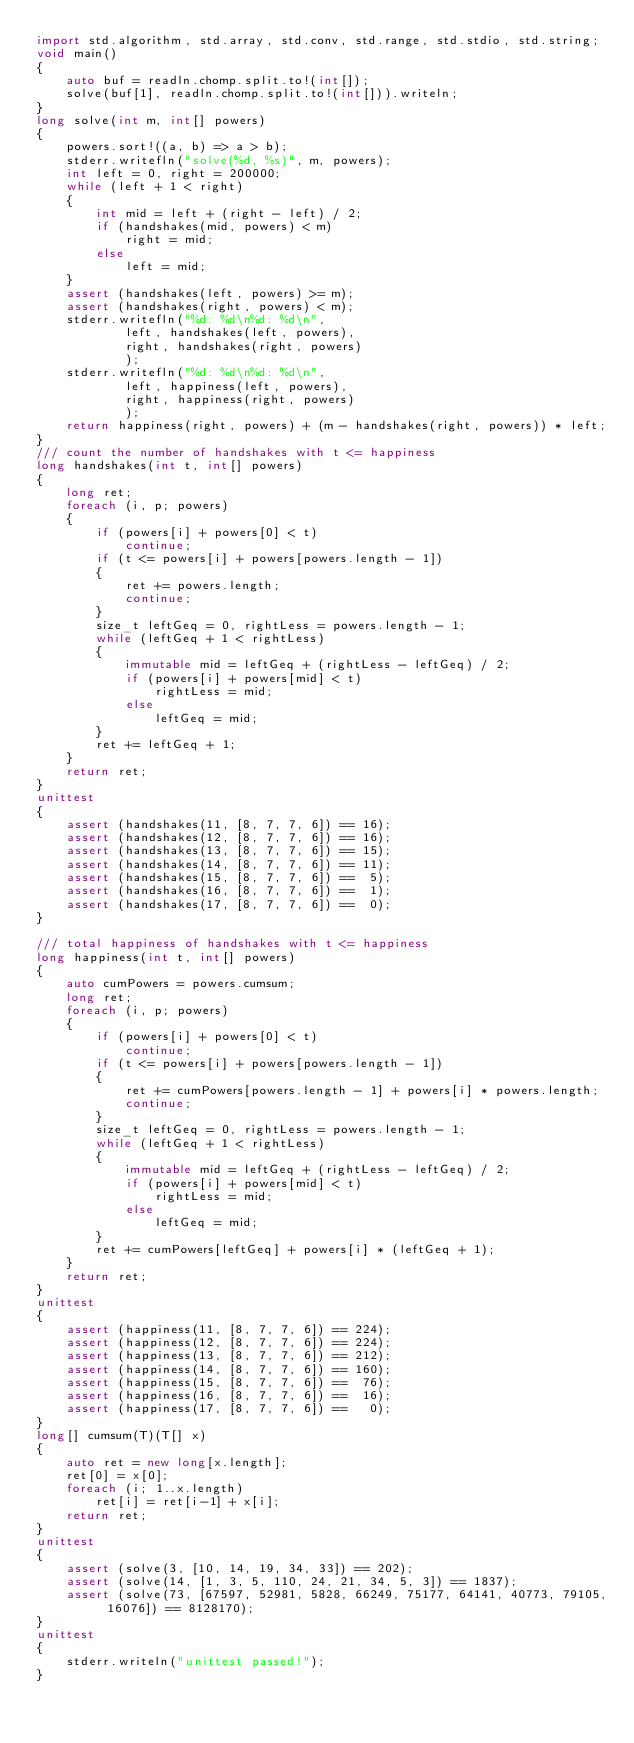Convert code to text. <code><loc_0><loc_0><loc_500><loc_500><_D_>import std.algorithm, std.array, std.conv, std.range, std.stdio, std.string;
void main()
{
    auto buf = readln.chomp.split.to!(int[]);
    solve(buf[1], readln.chomp.split.to!(int[])).writeln;
}
long solve(int m, int[] powers)
{
    powers.sort!((a, b) => a > b);
    stderr.writefln("solve(%d, %s)", m, powers);
    int left = 0, right = 200000;
    while (left + 1 < right)
    {
        int mid = left + (right - left) / 2;
        if (handshakes(mid, powers) < m)
            right = mid;
        else
            left = mid;
    }
    assert (handshakes(left, powers) >= m);
    assert (handshakes(right, powers) < m);
    stderr.writefln("%d: %d\n%d: %d\n",
            left, handshakes(left, powers),
            right, handshakes(right, powers)
            );
    stderr.writefln("%d: %d\n%d: %d\n",
            left, happiness(left, powers),
            right, happiness(right, powers)
            );
    return happiness(right, powers) + (m - handshakes(right, powers)) * left;
}
/// count the number of handshakes with t <= happiness
long handshakes(int t, int[] powers)
{
    long ret;
    foreach (i, p; powers)
    {
        if (powers[i] + powers[0] < t)
            continue;
        if (t <= powers[i] + powers[powers.length - 1])
        {
            ret += powers.length;
            continue;
        }
        size_t leftGeq = 0, rightLess = powers.length - 1;
        while (leftGeq + 1 < rightLess)
        {
            immutable mid = leftGeq + (rightLess - leftGeq) / 2;
            if (powers[i] + powers[mid] < t)
                rightLess = mid;
            else
                leftGeq = mid;
        }
        ret += leftGeq + 1;
    }
    return ret;
}
unittest
{
    assert (handshakes(11, [8, 7, 7, 6]) == 16);
    assert (handshakes(12, [8, 7, 7, 6]) == 16);
    assert (handshakes(13, [8, 7, 7, 6]) == 15);
    assert (handshakes(14, [8, 7, 7, 6]) == 11);
    assert (handshakes(15, [8, 7, 7, 6]) ==  5);
    assert (handshakes(16, [8, 7, 7, 6]) ==  1);
    assert (handshakes(17, [8, 7, 7, 6]) ==  0);
}

/// total happiness of handshakes with t <= happiness
long happiness(int t, int[] powers)
{
    auto cumPowers = powers.cumsum;
    long ret;
    foreach (i, p; powers)
    {
        if (powers[i] + powers[0] < t)
            continue;
        if (t <= powers[i] + powers[powers.length - 1])
        {
            ret += cumPowers[powers.length - 1] + powers[i] * powers.length;
            continue;
        }
        size_t leftGeq = 0, rightLess = powers.length - 1;
        while (leftGeq + 1 < rightLess)
        {
            immutable mid = leftGeq + (rightLess - leftGeq) / 2;
            if (powers[i] + powers[mid] < t)
                rightLess = mid;
            else
                leftGeq = mid;
        }
        ret += cumPowers[leftGeq] + powers[i] * (leftGeq + 1);
    }
    return ret;
}
unittest
{
    assert (happiness(11, [8, 7, 7, 6]) == 224);
    assert (happiness(12, [8, 7, 7, 6]) == 224);
    assert (happiness(13, [8, 7, 7, 6]) == 212);
    assert (happiness(14, [8, 7, 7, 6]) == 160);
    assert (happiness(15, [8, 7, 7, 6]) ==  76);
    assert (happiness(16, [8, 7, 7, 6]) ==  16);
    assert (happiness(17, [8, 7, 7, 6]) ==   0);
}
long[] cumsum(T)(T[] x)
{
    auto ret = new long[x.length];
    ret[0] = x[0];
    foreach (i; 1..x.length)
        ret[i] = ret[i-1] + x[i];
    return ret;
}
unittest
{
    assert (solve(3, [10, 14, 19, 34, 33]) == 202);
    assert (solve(14, [1, 3, 5, 110, 24, 21, 34, 5, 3]) == 1837);
    assert (solve(73, [67597, 52981, 5828, 66249, 75177, 64141, 40773, 79105, 16076]) == 8128170);
}
unittest
{
    stderr.writeln("unittest passed!");
}
</code> 